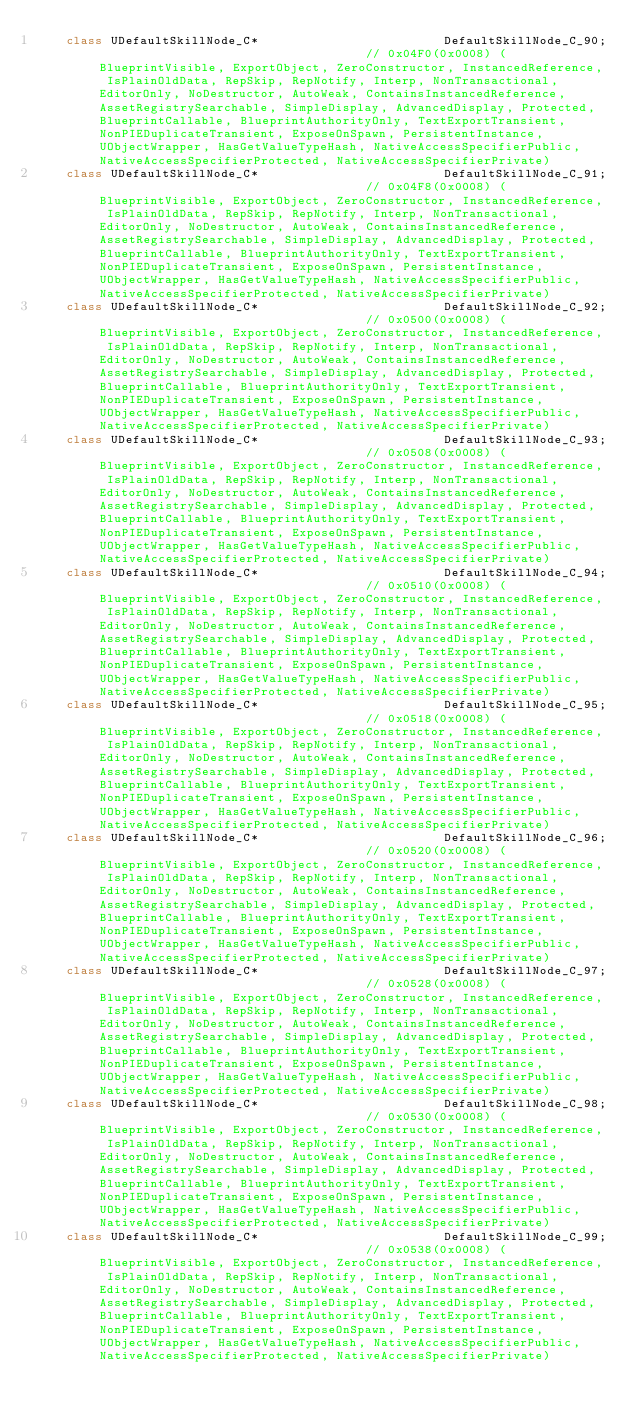Convert code to text. <code><loc_0><loc_0><loc_500><loc_500><_C++_>	class UDefaultSkillNode_C*                         DefaultSkillNode_C_90;                                    // 0x04F0(0x0008) (BlueprintVisible, ExportObject, ZeroConstructor, InstancedReference, IsPlainOldData, RepSkip, RepNotify, Interp, NonTransactional, EditorOnly, NoDestructor, AutoWeak, ContainsInstancedReference, AssetRegistrySearchable, SimpleDisplay, AdvancedDisplay, Protected, BlueprintCallable, BlueprintAuthorityOnly, TextExportTransient, NonPIEDuplicateTransient, ExposeOnSpawn, PersistentInstance, UObjectWrapper, HasGetValueTypeHash, NativeAccessSpecifierPublic, NativeAccessSpecifierProtected, NativeAccessSpecifierPrivate)
	class UDefaultSkillNode_C*                         DefaultSkillNode_C_91;                                    // 0x04F8(0x0008) (BlueprintVisible, ExportObject, ZeroConstructor, InstancedReference, IsPlainOldData, RepSkip, RepNotify, Interp, NonTransactional, EditorOnly, NoDestructor, AutoWeak, ContainsInstancedReference, AssetRegistrySearchable, SimpleDisplay, AdvancedDisplay, Protected, BlueprintCallable, BlueprintAuthorityOnly, TextExportTransient, NonPIEDuplicateTransient, ExposeOnSpawn, PersistentInstance, UObjectWrapper, HasGetValueTypeHash, NativeAccessSpecifierPublic, NativeAccessSpecifierProtected, NativeAccessSpecifierPrivate)
	class UDefaultSkillNode_C*                         DefaultSkillNode_C_92;                                    // 0x0500(0x0008) (BlueprintVisible, ExportObject, ZeroConstructor, InstancedReference, IsPlainOldData, RepSkip, RepNotify, Interp, NonTransactional, EditorOnly, NoDestructor, AutoWeak, ContainsInstancedReference, AssetRegistrySearchable, SimpleDisplay, AdvancedDisplay, Protected, BlueprintCallable, BlueprintAuthorityOnly, TextExportTransient, NonPIEDuplicateTransient, ExposeOnSpawn, PersistentInstance, UObjectWrapper, HasGetValueTypeHash, NativeAccessSpecifierPublic, NativeAccessSpecifierProtected, NativeAccessSpecifierPrivate)
	class UDefaultSkillNode_C*                         DefaultSkillNode_C_93;                                    // 0x0508(0x0008) (BlueprintVisible, ExportObject, ZeroConstructor, InstancedReference, IsPlainOldData, RepSkip, RepNotify, Interp, NonTransactional, EditorOnly, NoDestructor, AutoWeak, ContainsInstancedReference, AssetRegistrySearchable, SimpleDisplay, AdvancedDisplay, Protected, BlueprintCallable, BlueprintAuthorityOnly, TextExportTransient, NonPIEDuplicateTransient, ExposeOnSpawn, PersistentInstance, UObjectWrapper, HasGetValueTypeHash, NativeAccessSpecifierPublic, NativeAccessSpecifierProtected, NativeAccessSpecifierPrivate)
	class UDefaultSkillNode_C*                         DefaultSkillNode_C_94;                                    // 0x0510(0x0008) (BlueprintVisible, ExportObject, ZeroConstructor, InstancedReference, IsPlainOldData, RepSkip, RepNotify, Interp, NonTransactional, EditorOnly, NoDestructor, AutoWeak, ContainsInstancedReference, AssetRegistrySearchable, SimpleDisplay, AdvancedDisplay, Protected, BlueprintCallable, BlueprintAuthorityOnly, TextExportTransient, NonPIEDuplicateTransient, ExposeOnSpawn, PersistentInstance, UObjectWrapper, HasGetValueTypeHash, NativeAccessSpecifierPublic, NativeAccessSpecifierProtected, NativeAccessSpecifierPrivate)
	class UDefaultSkillNode_C*                         DefaultSkillNode_C_95;                                    // 0x0518(0x0008) (BlueprintVisible, ExportObject, ZeroConstructor, InstancedReference, IsPlainOldData, RepSkip, RepNotify, Interp, NonTransactional, EditorOnly, NoDestructor, AutoWeak, ContainsInstancedReference, AssetRegistrySearchable, SimpleDisplay, AdvancedDisplay, Protected, BlueprintCallable, BlueprintAuthorityOnly, TextExportTransient, NonPIEDuplicateTransient, ExposeOnSpawn, PersistentInstance, UObjectWrapper, HasGetValueTypeHash, NativeAccessSpecifierPublic, NativeAccessSpecifierProtected, NativeAccessSpecifierPrivate)
	class UDefaultSkillNode_C*                         DefaultSkillNode_C_96;                                    // 0x0520(0x0008) (BlueprintVisible, ExportObject, ZeroConstructor, InstancedReference, IsPlainOldData, RepSkip, RepNotify, Interp, NonTransactional, EditorOnly, NoDestructor, AutoWeak, ContainsInstancedReference, AssetRegistrySearchable, SimpleDisplay, AdvancedDisplay, Protected, BlueprintCallable, BlueprintAuthorityOnly, TextExportTransient, NonPIEDuplicateTransient, ExposeOnSpawn, PersistentInstance, UObjectWrapper, HasGetValueTypeHash, NativeAccessSpecifierPublic, NativeAccessSpecifierProtected, NativeAccessSpecifierPrivate)
	class UDefaultSkillNode_C*                         DefaultSkillNode_C_97;                                    // 0x0528(0x0008) (BlueprintVisible, ExportObject, ZeroConstructor, InstancedReference, IsPlainOldData, RepSkip, RepNotify, Interp, NonTransactional, EditorOnly, NoDestructor, AutoWeak, ContainsInstancedReference, AssetRegistrySearchable, SimpleDisplay, AdvancedDisplay, Protected, BlueprintCallable, BlueprintAuthorityOnly, TextExportTransient, NonPIEDuplicateTransient, ExposeOnSpawn, PersistentInstance, UObjectWrapper, HasGetValueTypeHash, NativeAccessSpecifierPublic, NativeAccessSpecifierProtected, NativeAccessSpecifierPrivate)
	class UDefaultSkillNode_C*                         DefaultSkillNode_C_98;                                    // 0x0530(0x0008) (BlueprintVisible, ExportObject, ZeroConstructor, InstancedReference, IsPlainOldData, RepSkip, RepNotify, Interp, NonTransactional, EditorOnly, NoDestructor, AutoWeak, ContainsInstancedReference, AssetRegistrySearchable, SimpleDisplay, AdvancedDisplay, Protected, BlueprintCallable, BlueprintAuthorityOnly, TextExportTransient, NonPIEDuplicateTransient, ExposeOnSpawn, PersistentInstance, UObjectWrapper, HasGetValueTypeHash, NativeAccessSpecifierPublic, NativeAccessSpecifierProtected, NativeAccessSpecifierPrivate)
	class UDefaultSkillNode_C*                         DefaultSkillNode_C_99;                                    // 0x0538(0x0008) (BlueprintVisible, ExportObject, ZeroConstructor, InstancedReference, IsPlainOldData, RepSkip, RepNotify, Interp, NonTransactional, EditorOnly, NoDestructor, AutoWeak, ContainsInstancedReference, AssetRegistrySearchable, SimpleDisplay, AdvancedDisplay, Protected, BlueprintCallable, BlueprintAuthorityOnly, TextExportTransient, NonPIEDuplicateTransient, ExposeOnSpawn, PersistentInstance, UObjectWrapper, HasGetValueTypeHash, NativeAccessSpecifierPublic, NativeAccessSpecifierProtected, NativeAccessSpecifierPrivate)</code> 